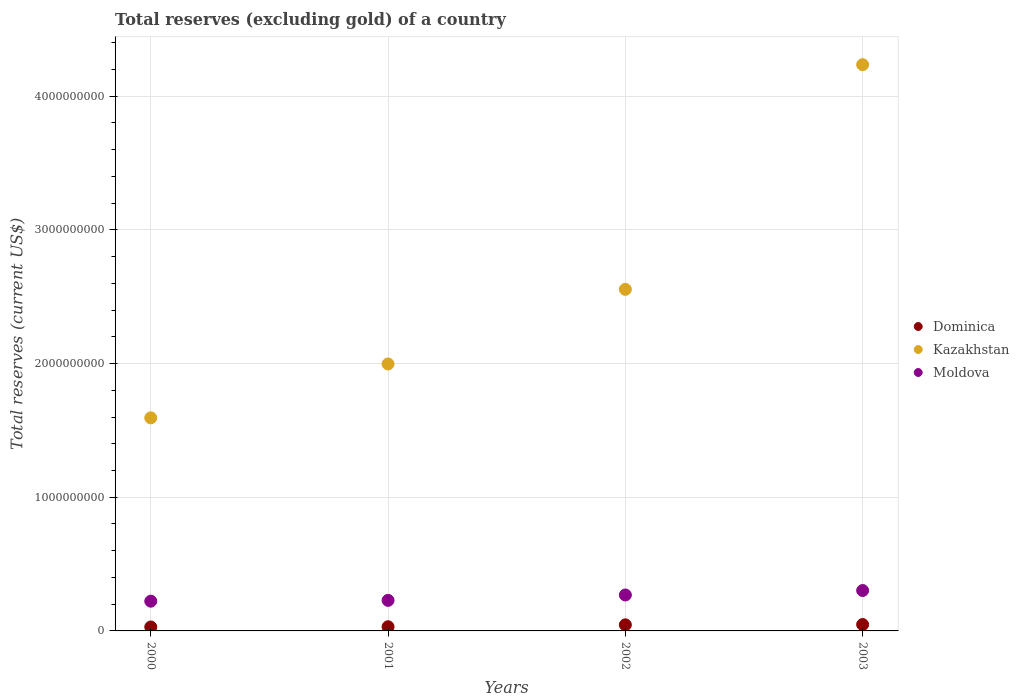How many different coloured dotlines are there?
Provide a short and direct response. 3. Is the number of dotlines equal to the number of legend labels?
Provide a succinct answer. Yes. What is the total reserves (excluding gold) in Dominica in 2002?
Your answer should be compact. 4.55e+07. Across all years, what is the maximum total reserves (excluding gold) in Dominica?
Provide a short and direct response. 4.77e+07. Across all years, what is the minimum total reserves (excluding gold) in Dominica?
Your answer should be very brief. 2.94e+07. In which year was the total reserves (excluding gold) in Moldova maximum?
Keep it short and to the point. 2003. What is the total total reserves (excluding gold) in Moldova in the graph?
Your answer should be compact. 1.02e+09. What is the difference between the total reserves (excluding gold) in Moldova in 2000 and that in 2002?
Your response must be concise. -4.64e+07. What is the difference between the total reserves (excluding gold) in Kazakhstan in 2003 and the total reserves (excluding gold) in Dominica in 2001?
Provide a short and direct response. 4.20e+09. What is the average total reserves (excluding gold) in Dominica per year?
Your answer should be compact. 3.85e+07. In the year 2001, what is the difference between the total reserves (excluding gold) in Kazakhstan and total reserves (excluding gold) in Dominica?
Ensure brevity in your answer.  1.97e+09. In how many years, is the total reserves (excluding gold) in Kazakhstan greater than 800000000 US$?
Your response must be concise. 4. What is the ratio of the total reserves (excluding gold) in Moldova in 2000 to that in 2003?
Your response must be concise. 0.74. What is the difference between the highest and the second highest total reserves (excluding gold) in Moldova?
Offer a terse response. 3.34e+07. What is the difference between the highest and the lowest total reserves (excluding gold) in Kazakhstan?
Provide a short and direct response. 2.64e+09. Does the total reserves (excluding gold) in Kazakhstan monotonically increase over the years?
Your response must be concise. Yes. How many dotlines are there?
Offer a terse response. 3. How many years are there in the graph?
Provide a short and direct response. 4. Are the values on the major ticks of Y-axis written in scientific E-notation?
Offer a very short reply. No. Does the graph contain any zero values?
Ensure brevity in your answer.  No. How are the legend labels stacked?
Offer a very short reply. Vertical. What is the title of the graph?
Make the answer very short. Total reserves (excluding gold) of a country. What is the label or title of the Y-axis?
Offer a terse response. Total reserves (current US$). What is the Total reserves (current US$) of Dominica in 2000?
Provide a short and direct response. 2.94e+07. What is the Total reserves (current US$) in Kazakhstan in 2000?
Provide a succinct answer. 1.59e+09. What is the Total reserves (current US$) of Moldova in 2000?
Offer a terse response. 2.22e+08. What is the Total reserves (current US$) of Dominica in 2001?
Provide a succinct answer. 3.12e+07. What is the Total reserves (current US$) in Kazakhstan in 2001?
Provide a succinct answer. 2.00e+09. What is the Total reserves (current US$) in Moldova in 2001?
Keep it short and to the point. 2.29e+08. What is the Total reserves (current US$) of Dominica in 2002?
Offer a terse response. 4.55e+07. What is the Total reserves (current US$) of Kazakhstan in 2002?
Provide a succinct answer. 2.56e+09. What is the Total reserves (current US$) of Moldova in 2002?
Your response must be concise. 2.69e+08. What is the Total reserves (current US$) in Dominica in 2003?
Ensure brevity in your answer.  4.77e+07. What is the Total reserves (current US$) of Kazakhstan in 2003?
Ensure brevity in your answer.  4.24e+09. What is the Total reserves (current US$) in Moldova in 2003?
Offer a terse response. 3.02e+08. Across all years, what is the maximum Total reserves (current US$) in Dominica?
Offer a very short reply. 4.77e+07. Across all years, what is the maximum Total reserves (current US$) of Kazakhstan?
Provide a succinct answer. 4.24e+09. Across all years, what is the maximum Total reserves (current US$) in Moldova?
Your response must be concise. 3.02e+08. Across all years, what is the minimum Total reserves (current US$) in Dominica?
Provide a short and direct response. 2.94e+07. Across all years, what is the minimum Total reserves (current US$) in Kazakhstan?
Provide a short and direct response. 1.59e+09. Across all years, what is the minimum Total reserves (current US$) in Moldova?
Provide a succinct answer. 2.22e+08. What is the total Total reserves (current US$) of Dominica in the graph?
Offer a very short reply. 1.54e+08. What is the total Total reserves (current US$) of Kazakhstan in the graph?
Ensure brevity in your answer.  1.04e+1. What is the total Total reserves (current US$) in Moldova in the graph?
Give a very brief answer. 1.02e+09. What is the difference between the Total reserves (current US$) of Dominica in 2000 and that in 2001?
Provide a short and direct response. -1.85e+06. What is the difference between the Total reserves (current US$) of Kazakhstan in 2000 and that in 2001?
Your answer should be very brief. -4.03e+08. What is the difference between the Total reserves (current US$) in Moldova in 2000 and that in 2001?
Keep it short and to the point. -6.04e+06. What is the difference between the Total reserves (current US$) in Dominica in 2000 and that in 2002?
Keep it short and to the point. -1.61e+07. What is the difference between the Total reserves (current US$) in Kazakhstan in 2000 and that in 2002?
Give a very brief answer. -9.61e+08. What is the difference between the Total reserves (current US$) in Moldova in 2000 and that in 2002?
Provide a succinct answer. -4.64e+07. What is the difference between the Total reserves (current US$) in Dominica in 2000 and that in 2003?
Give a very brief answer. -1.84e+07. What is the difference between the Total reserves (current US$) in Kazakhstan in 2000 and that in 2003?
Offer a very short reply. -2.64e+09. What is the difference between the Total reserves (current US$) of Moldova in 2000 and that in 2003?
Make the answer very short. -7.98e+07. What is the difference between the Total reserves (current US$) of Dominica in 2001 and that in 2002?
Your response must be concise. -1.43e+07. What is the difference between the Total reserves (current US$) of Kazakhstan in 2001 and that in 2002?
Offer a very short reply. -5.58e+08. What is the difference between the Total reserves (current US$) of Moldova in 2001 and that in 2002?
Ensure brevity in your answer.  -4.03e+07. What is the difference between the Total reserves (current US$) in Dominica in 2001 and that in 2003?
Make the answer very short. -1.65e+07. What is the difference between the Total reserves (current US$) of Kazakhstan in 2001 and that in 2003?
Make the answer very short. -2.24e+09. What is the difference between the Total reserves (current US$) of Moldova in 2001 and that in 2003?
Make the answer very short. -7.37e+07. What is the difference between the Total reserves (current US$) of Dominica in 2002 and that in 2003?
Give a very brief answer. -2.24e+06. What is the difference between the Total reserves (current US$) in Kazakhstan in 2002 and that in 2003?
Offer a terse response. -1.68e+09. What is the difference between the Total reserves (current US$) in Moldova in 2002 and that in 2003?
Keep it short and to the point. -3.34e+07. What is the difference between the Total reserves (current US$) of Dominica in 2000 and the Total reserves (current US$) of Kazakhstan in 2001?
Ensure brevity in your answer.  -1.97e+09. What is the difference between the Total reserves (current US$) of Dominica in 2000 and the Total reserves (current US$) of Moldova in 2001?
Give a very brief answer. -1.99e+08. What is the difference between the Total reserves (current US$) of Kazakhstan in 2000 and the Total reserves (current US$) of Moldova in 2001?
Provide a short and direct response. 1.37e+09. What is the difference between the Total reserves (current US$) in Dominica in 2000 and the Total reserves (current US$) in Kazakhstan in 2002?
Your response must be concise. -2.53e+09. What is the difference between the Total reserves (current US$) of Dominica in 2000 and the Total reserves (current US$) of Moldova in 2002?
Your answer should be compact. -2.39e+08. What is the difference between the Total reserves (current US$) of Kazakhstan in 2000 and the Total reserves (current US$) of Moldova in 2002?
Offer a very short reply. 1.33e+09. What is the difference between the Total reserves (current US$) in Dominica in 2000 and the Total reserves (current US$) in Kazakhstan in 2003?
Your answer should be compact. -4.21e+09. What is the difference between the Total reserves (current US$) in Dominica in 2000 and the Total reserves (current US$) in Moldova in 2003?
Ensure brevity in your answer.  -2.73e+08. What is the difference between the Total reserves (current US$) of Kazakhstan in 2000 and the Total reserves (current US$) of Moldova in 2003?
Make the answer very short. 1.29e+09. What is the difference between the Total reserves (current US$) of Dominica in 2001 and the Total reserves (current US$) of Kazakhstan in 2002?
Your response must be concise. -2.52e+09. What is the difference between the Total reserves (current US$) of Dominica in 2001 and the Total reserves (current US$) of Moldova in 2002?
Offer a very short reply. -2.38e+08. What is the difference between the Total reserves (current US$) in Kazakhstan in 2001 and the Total reserves (current US$) in Moldova in 2002?
Provide a succinct answer. 1.73e+09. What is the difference between the Total reserves (current US$) in Dominica in 2001 and the Total reserves (current US$) in Kazakhstan in 2003?
Ensure brevity in your answer.  -4.20e+09. What is the difference between the Total reserves (current US$) of Dominica in 2001 and the Total reserves (current US$) of Moldova in 2003?
Give a very brief answer. -2.71e+08. What is the difference between the Total reserves (current US$) in Kazakhstan in 2001 and the Total reserves (current US$) in Moldova in 2003?
Your answer should be very brief. 1.69e+09. What is the difference between the Total reserves (current US$) of Dominica in 2002 and the Total reserves (current US$) of Kazakhstan in 2003?
Your response must be concise. -4.19e+09. What is the difference between the Total reserves (current US$) in Dominica in 2002 and the Total reserves (current US$) in Moldova in 2003?
Provide a succinct answer. -2.57e+08. What is the difference between the Total reserves (current US$) in Kazakhstan in 2002 and the Total reserves (current US$) in Moldova in 2003?
Keep it short and to the point. 2.25e+09. What is the average Total reserves (current US$) in Dominica per year?
Make the answer very short. 3.85e+07. What is the average Total reserves (current US$) in Kazakhstan per year?
Offer a terse response. 2.60e+09. What is the average Total reserves (current US$) in Moldova per year?
Your answer should be compact. 2.56e+08. In the year 2000, what is the difference between the Total reserves (current US$) of Dominica and Total reserves (current US$) of Kazakhstan?
Your answer should be very brief. -1.56e+09. In the year 2000, what is the difference between the Total reserves (current US$) in Dominica and Total reserves (current US$) in Moldova?
Provide a succinct answer. -1.93e+08. In the year 2000, what is the difference between the Total reserves (current US$) of Kazakhstan and Total reserves (current US$) of Moldova?
Offer a very short reply. 1.37e+09. In the year 2001, what is the difference between the Total reserves (current US$) in Dominica and Total reserves (current US$) in Kazakhstan?
Keep it short and to the point. -1.97e+09. In the year 2001, what is the difference between the Total reserves (current US$) in Dominica and Total reserves (current US$) in Moldova?
Provide a succinct answer. -1.97e+08. In the year 2001, what is the difference between the Total reserves (current US$) in Kazakhstan and Total reserves (current US$) in Moldova?
Your answer should be compact. 1.77e+09. In the year 2002, what is the difference between the Total reserves (current US$) in Dominica and Total reserves (current US$) in Kazakhstan?
Provide a short and direct response. -2.51e+09. In the year 2002, what is the difference between the Total reserves (current US$) in Dominica and Total reserves (current US$) in Moldova?
Your answer should be very brief. -2.23e+08. In the year 2002, what is the difference between the Total reserves (current US$) of Kazakhstan and Total reserves (current US$) of Moldova?
Your answer should be very brief. 2.29e+09. In the year 2003, what is the difference between the Total reserves (current US$) of Dominica and Total reserves (current US$) of Kazakhstan?
Keep it short and to the point. -4.19e+09. In the year 2003, what is the difference between the Total reserves (current US$) of Dominica and Total reserves (current US$) of Moldova?
Your answer should be very brief. -2.55e+08. In the year 2003, what is the difference between the Total reserves (current US$) in Kazakhstan and Total reserves (current US$) in Moldova?
Make the answer very short. 3.93e+09. What is the ratio of the Total reserves (current US$) in Dominica in 2000 to that in 2001?
Provide a short and direct response. 0.94. What is the ratio of the Total reserves (current US$) of Kazakhstan in 2000 to that in 2001?
Provide a succinct answer. 0.8. What is the ratio of the Total reserves (current US$) of Moldova in 2000 to that in 2001?
Offer a very short reply. 0.97. What is the ratio of the Total reserves (current US$) in Dominica in 2000 to that in 2002?
Your answer should be compact. 0.65. What is the ratio of the Total reserves (current US$) of Kazakhstan in 2000 to that in 2002?
Provide a short and direct response. 0.62. What is the ratio of the Total reserves (current US$) of Moldova in 2000 to that in 2002?
Offer a terse response. 0.83. What is the ratio of the Total reserves (current US$) in Dominica in 2000 to that in 2003?
Your answer should be compact. 0.62. What is the ratio of the Total reserves (current US$) of Kazakhstan in 2000 to that in 2003?
Ensure brevity in your answer.  0.38. What is the ratio of the Total reserves (current US$) of Moldova in 2000 to that in 2003?
Provide a succinct answer. 0.74. What is the ratio of the Total reserves (current US$) in Dominica in 2001 to that in 2002?
Ensure brevity in your answer.  0.69. What is the ratio of the Total reserves (current US$) in Kazakhstan in 2001 to that in 2002?
Your response must be concise. 0.78. What is the ratio of the Total reserves (current US$) in Moldova in 2001 to that in 2002?
Offer a terse response. 0.85. What is the ratio of the Total reserves (current US$) of Dominica in 2001 to that in 2003?
Keep it short and to the point. 0.65. What is the ratio of the Total reserves (current US$) of Kazakhstan in 2001 to that in 2003?
Offer a terse response. 0.47. What is the ratio of the Total reserves (current US$) in Moldova in 2001 to that in 2003?
Provide a succinct answer. 0.76. What is the ratio of the Total reserves (current US$) of Dominica in 2002 to that in 2003?
Your response must be concise. 0.95. What is the ratio of the Total reserves (current US$) in Kazakhstan in 2002 to that in 2003?
Offer a terse response. 0.6. What is the ratio of the Total reserves (current US$) in Moldova in 2002 to that in 2003?
Keep it short and to the point. 0.89. What is the difference between the highest and the second highest Total reserves (current US$) in Dominica?
Keep it short and to the point. 2.24e+06. What is the difference between the highest and the second highest Total reserves (current US$) in Kazakhstan?
Give a very brief answer. 1.68e+09. What is the difference between the highest and the second highest Total reserves (current US$) of Moldova?
Your answer should be very brief. 3.34e+07. What is the difference between the highest and the lowest Total reserves (current US$) of Dominica?
Give a very brief answer. 1.84e+07. What is the difference between the highest and the lowest Total reserves (current US$) in Kazakhstan?
Provide a succinct answer. 2.64e+09. What is the difference between the highest and the lowest Total reserves (current US$) of Moldova?
Offer a terse response. 7.98e+07. 